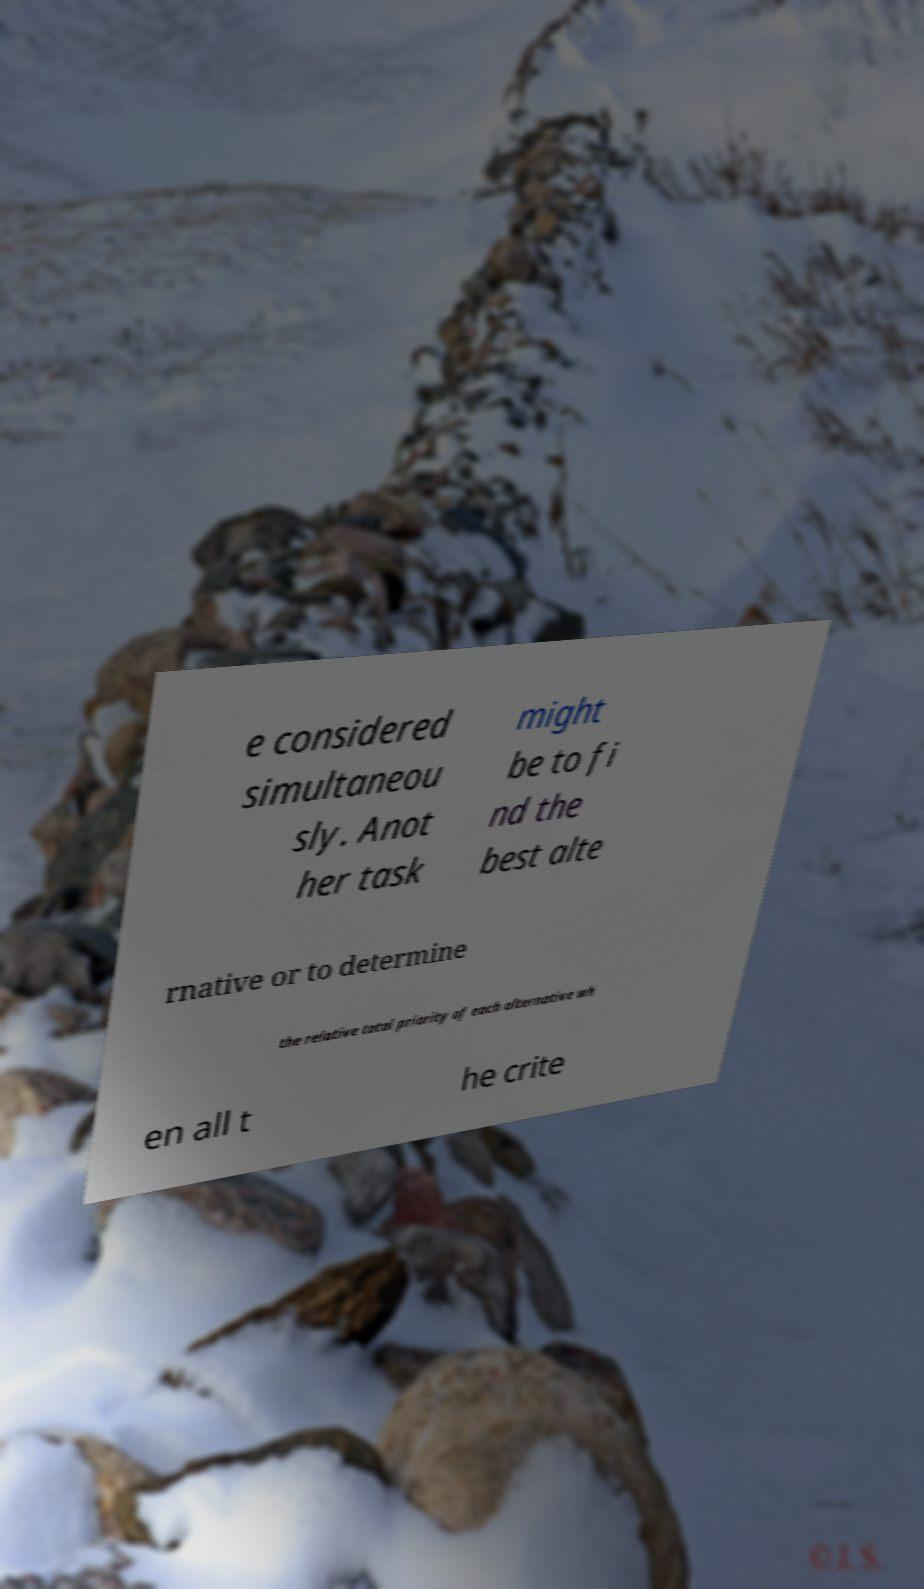Could you extract and type out the text from this image? e considered simultaneou sly. Anot her task might be to fi nd the best alte rnative or to determine the relative total priority of each alternative wh en all t he crite 